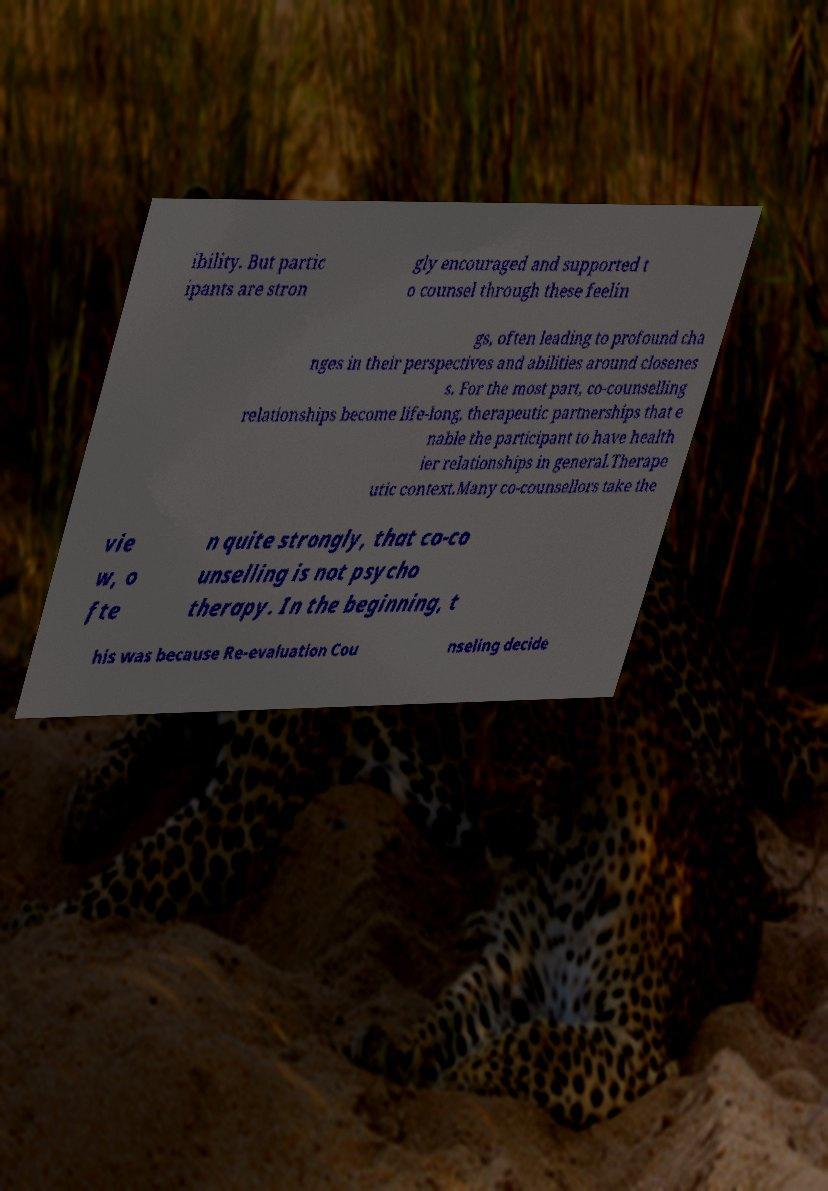Can you accurately transcribe the text from the provided image for me? ibility. But partic ipants are stron gly encouraged and supported t o counsel through these feelin gs, often leading to profound cha nges in their perspectives and abilities around closenes s. For the most part, co-counselling relationships become life-long, therapeutic partnerships that e nable the participant to have health ier relationships in general.Therape utic context.Many co-counsellors take the vie w, o fte n quite strongly, that co-co unselling is not psycho therapy. In the beginning, t his was because Re-evaluation Cou nseling decide 